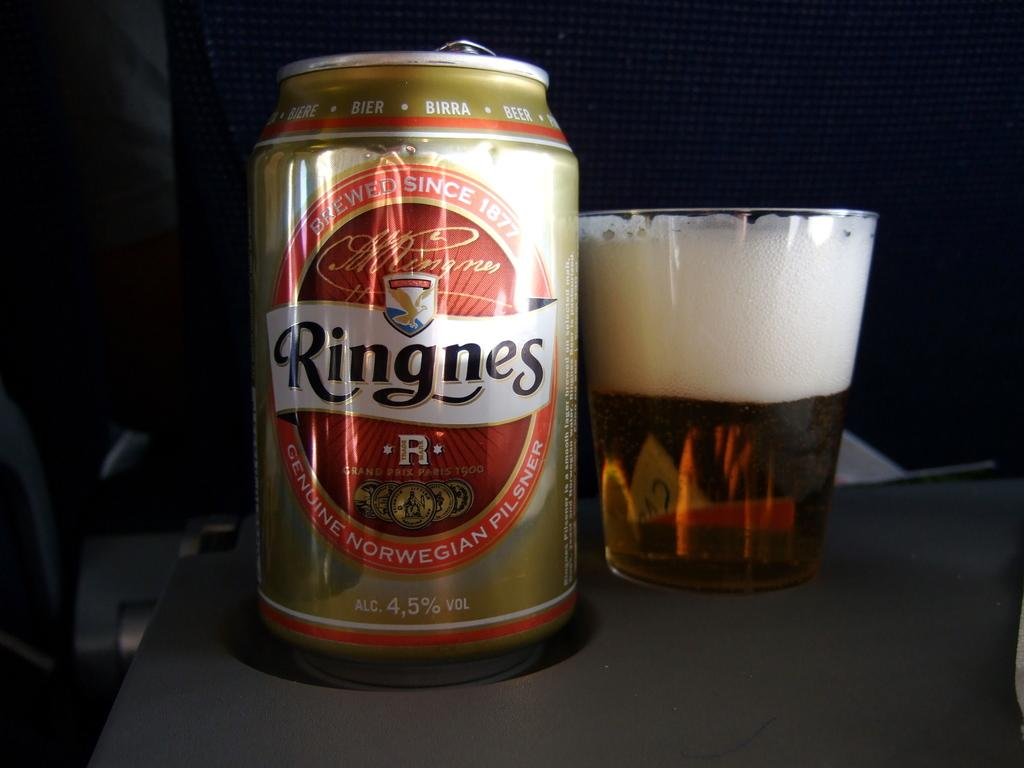<image>
Offer a succinct explanation of the picture presented. A shot of beer is poured from a can of Ringnes. 